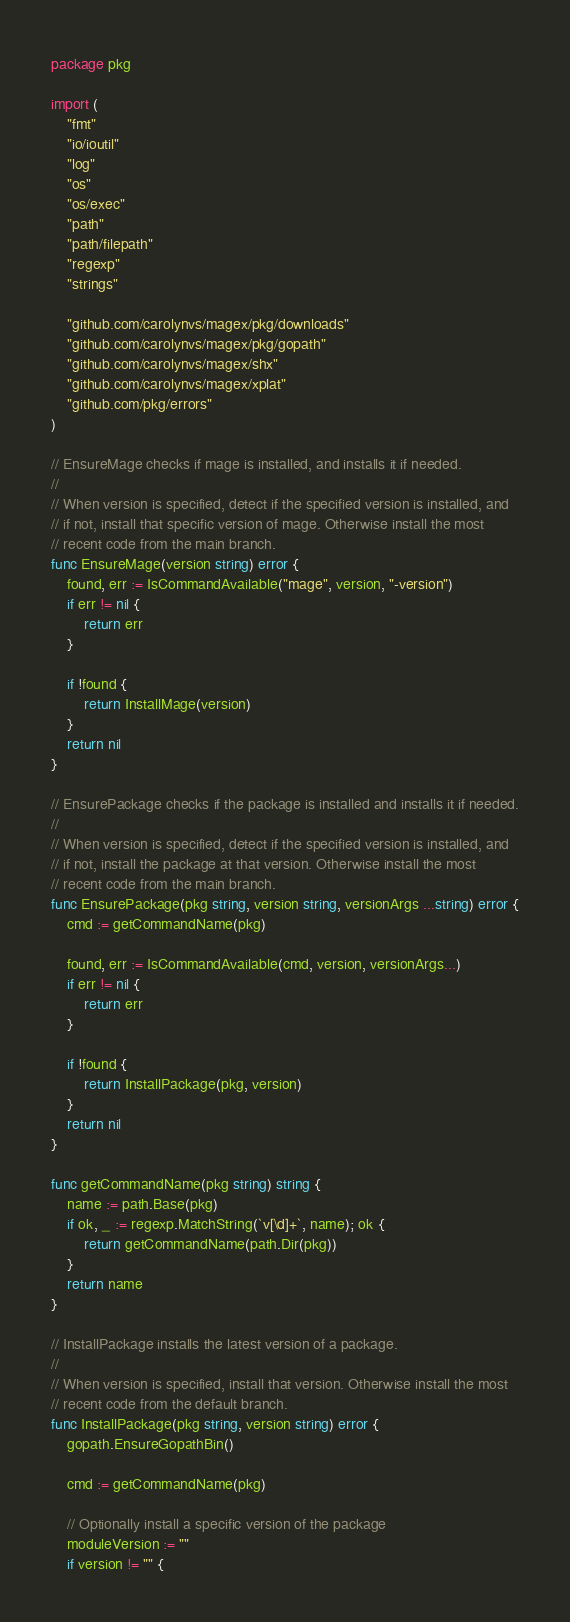Convert code to text. <code><loc_0><loc_0><loc_500><loc_500><_Go_>package pkg

import (
	"fmt"
	"io/ioutil"
	"log"
	"os"
	"os/exec"
	"path"
	"path/filepath"
	"regexp"
	"strings"

	"github.com/carolynvs/magex/pkg/downloads"
	"github.com/carolynvs/magex/pkg/gopath"
	"github.com/carolynvs/magex/shx"
	"github.com/carolynvs/magex/xplat"
	"github.com/pkg/errors"
)

// EnsureMage checks if mage is installed, and installs it if needed.
//
// When version is specified, detect if the specified version is installed, and
// if not, install that specific version of mage. Otherwise install the most
// recent code from the main branch.
func EnsureMage(version string) error {
	found, err := IsCommandAvailable("mage", version, "-version")
	if err != nil {
		return err
	}

	if !found {
		return InstallMage(version)
	}
	return nil
}

// EnsurePackage checks if the package is installed and installs it if needed.
//
// When version is specified, detect if the specified version is installed, and
// if not, install the package at that version. Otherwise install the most
// recent code from the main branch.
func EnsurePackage(pkg string, version string, versionArgs ...string) error {
	cmd := getCommandName(pkg)

	found, err := IsCommandAvailable(cmd, version, versionArgs...)
	if err != nil {
		return err
	}

	if !found {
		return InstallPackage(pkg, version)
	}
	return nil
}

func getCommandName(pkg string) string {
	name := path.Base(pkg)
	if ok, _ := regexp.MatchString(`v[\d]+`, name); ok {
		return getCommandName(path.Dir(pkg))
	}
	return name
}

// InstallPackage installs the latest version of a package.
//
// When version is specified, install that version. Otherwise install the most
// recent code from the default branch.
func InstallPackage(pkg string, version string) error {
	gopath.EnsureGopathBin()

	cmd := getCommandName(pkg)

	// Optionally install a specific version of the package
	moduleVersion := ""
	if version != "" {</code> 